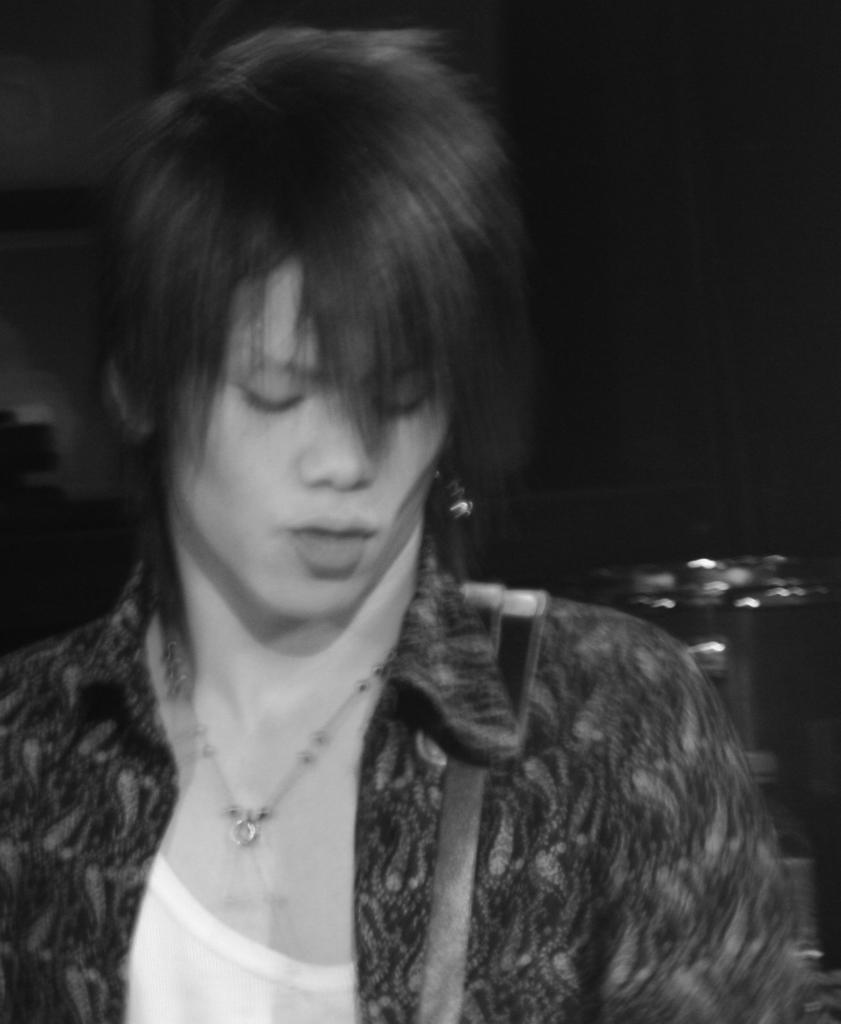How would you summarize this image in a sentence or two? In this black and white picture there is a woman standing. There is a strap on her shoulder. Behind her there is an object. The background is dark. 